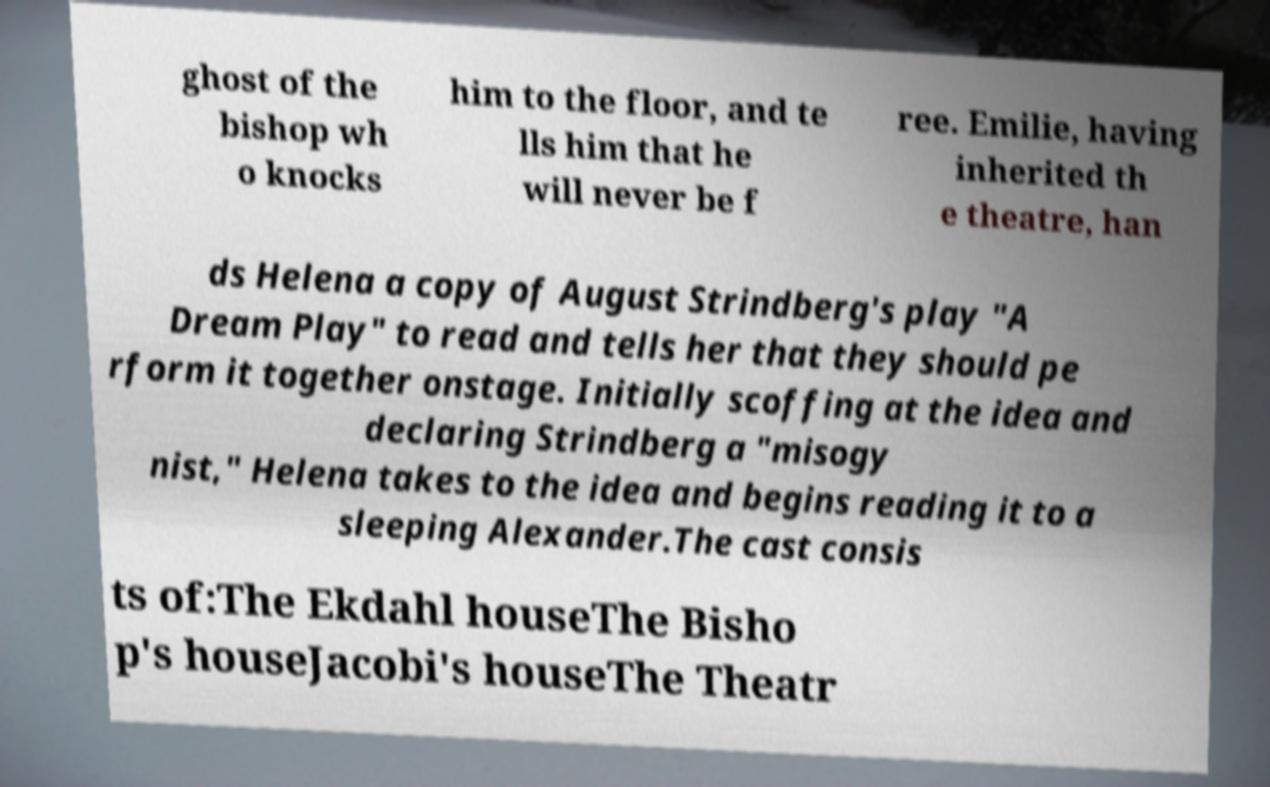Could you extract and type out the text from this image? ghost of the bishop wh o knocks him to the floor, and te lls him that he will never be f ree. Emilie, having inherited th e theatre, han ds Helena a copy of August Strindberg's play "A Dream Play" to read and tells her that they should pe rform it together onstage. Initially scoffing at the idea and declaring Strindberg a "misogy nist," Helena takes to the idea and begins reading it to a sleeping Alexander.The cast consis ts of:The Ekdahl houseThe Bisho p's houseJacobi's houseThe Theatr 